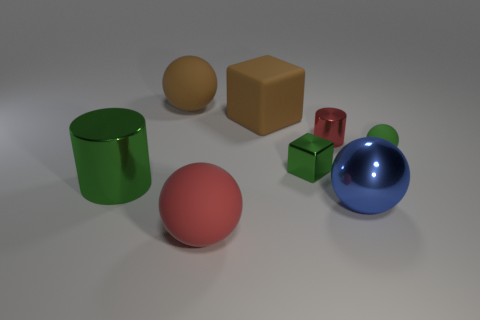How big is the green metal cylinder?
Give a very brief answer. Large. What number of blue shiny things are the same size as the green ball?
Make the answer very short. 0. Are there fewer tiny green metal objects on the left side of the small green cube than green cylinders in front of the small red metal cylinder?
Offer a very short reply. Yes. How big is the blue object that is in front of the metallic object left of the thing in front of the large blue shiny object?
Make the answer very short. Large. How big is the rubber sphere that is to the left of the big block and in front of the large brown matte sphere?
Keep it short and to the point. Large. There is a red thing that is behind the large metal object that is left of the small green shiny cube; what is its shape?
Keep it short and to the point. Cylinder. Are there any other things that are the same color as the matte cube?
Your response must be concise. Yes. The matte object behind the big brown rubber cube has what shape?
Your answer should be very brief. Sphere. There is a matte thing that is in front of the small shiny cylinder and on the left side of the tiny green metallic cube; what is its shape?
Offer a very short reply. Sphere. What number of blue objects are big cylinders or metallic objects?
Your answer should be very brief. 1. 